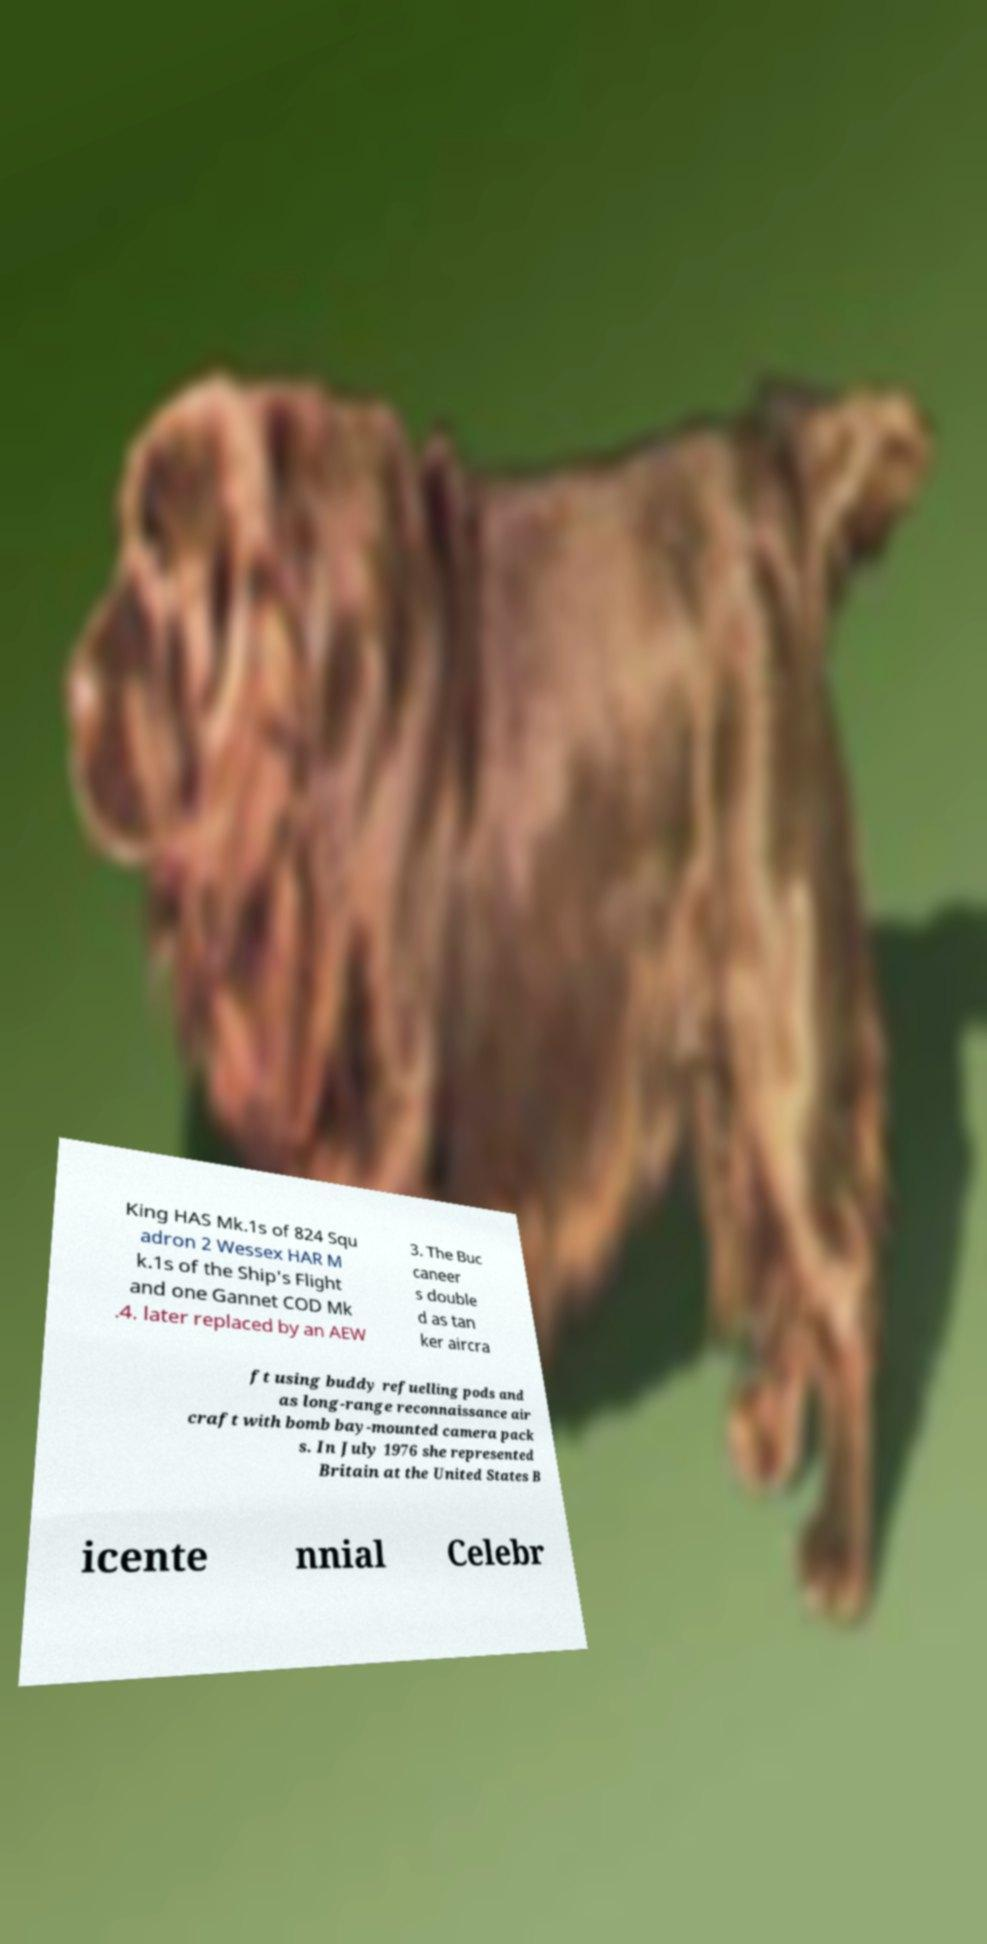Please identify and transcribe the text found in this image. King HAS Mk.1s of 824 Squ adron 2 Wessex HAR M k.1s of the Ship's Flight and one Gannet COD Mk .4. later replaced by an AEW 3. The Buc caneer s double d as tan ker aircra ft using buddy refuelling pods and as long-range reconnaissance air craft with bomb bay-mounted camera pack s. In July 1976 she represented Britain at the United States B icente nnial Celebr 